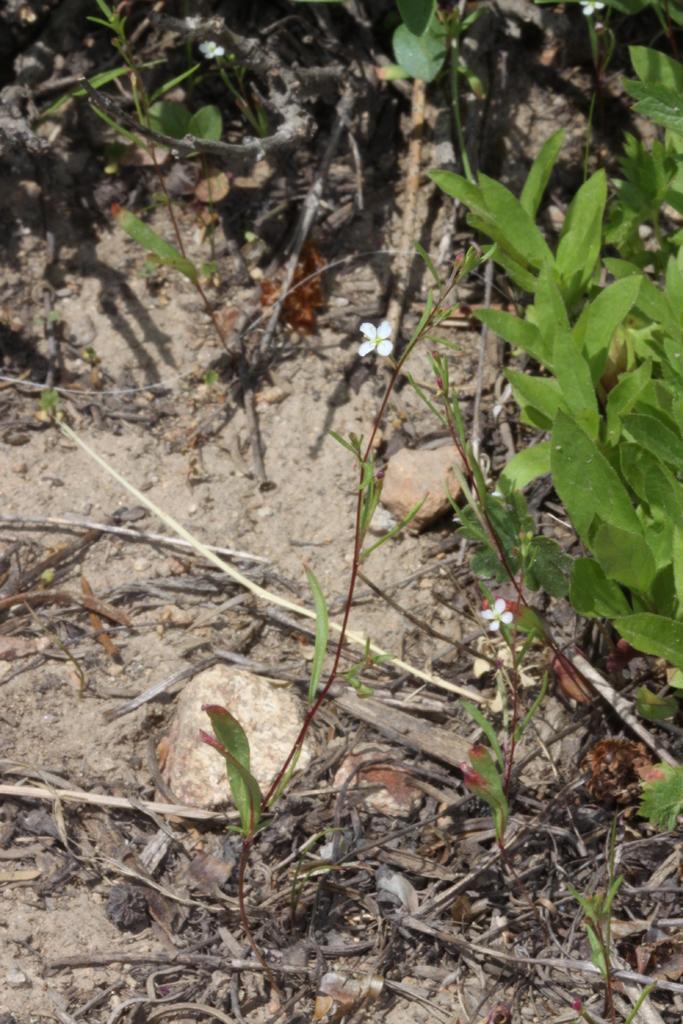In one or two sentences, can you explain what this image depicts? In this picture we can see plants and grass. Here we can see white color small flower. On the bottom left there is a stone. 